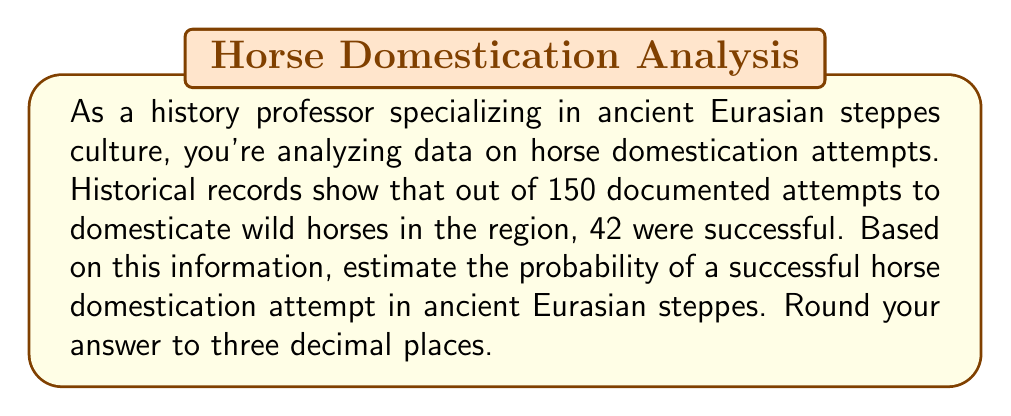Show me your answer to this math problem. To estimate the probability of successful horse domestication, we can use the concept of relative frequency as an approximation of probability. The relative frequency of an event is calculated by dividing the number of favorable outcomes by the total number of trials.

Let's define our variables:
$s$ = number of successful domestication attempts
$n$ = total number of domestication attempts

Given:
$s = 42$
$n = 150$

The probability of success, $p$, can be estimated as:

$$p = \frac{s}{n}$$

Substituting the values:

$$p = \frac{42}{150}$$

To calculate this:

$$p = \frac{42}{150} = 0.28$$

Rounding to three decimal places:

$$p \approx 0.280$$

This means that based on the historical data provided, there was approximately a 28.0% chance of successfully domesticating a horse in the ancient Eurasian steppes.

It's important to note that this is an estimate based on the available data and assumes that the recorded attempts are representative of all domestication efforts in the region. Factors such as specific time periods, geographic variations within the steppes, and the methods used for domestication could all influence the actual probability of success.
Answer: 0.280 